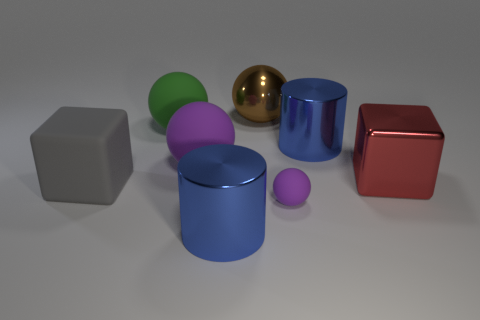Subtract all purple cubes. How many purple spheres are left? 2 Subtract all big spheres. How many spheres are left? 1 Add 2 small purple balls. How many objects exist? 10 Subtract all cyan spheres. Subtract all red blocks. How many spheres are left? 4 Subtract all cylinders. How many objects are left? 6 Add 5 purple spheres. How many purple spheres are left? 7 Add 5 large metal cubes. How many large metal cubes exist? 6 Subtract 0 gray cylinders. How many objects are left? 8 Subtract all large metal blocks. Subtract all big red things. How many objects are left? 6 